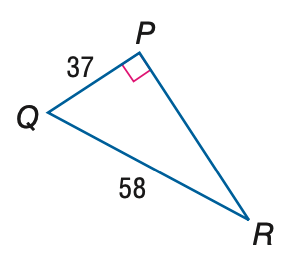Answer the mathemtical geometry problem and directly provide the correct option letter.
Question: Find the measure of \angle R to the nearest tenth.
Choices: A: 32.5 B: 39.6 C: 50.4 D: 57.5 B 